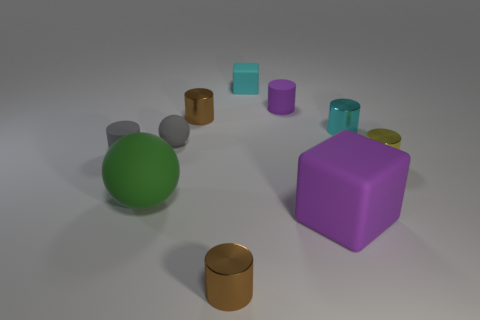Subtract 3 cylinders. How many cylinders are left? 3 Subtract all tiny yellow metal cylinders. How many cylinders are left? 5 Subtract all cyan cylinders. How many cylinders are left? 5 Subtract all cyan cylinders. Subtract all purple spheres. How many cylinders are left? 5 Subtract all cylinders. How many objects are left? 4 Add 8 small brown metal cylinders. How many small brown metal cylinders exist? 10 Subtract 0 red balls. How many objects are left? 10 Subtract all big green cylinders. Subtract all small rubber balls. How many objects are left? 9 Add 1 small rubber things. How many small rubber things are left? 5 